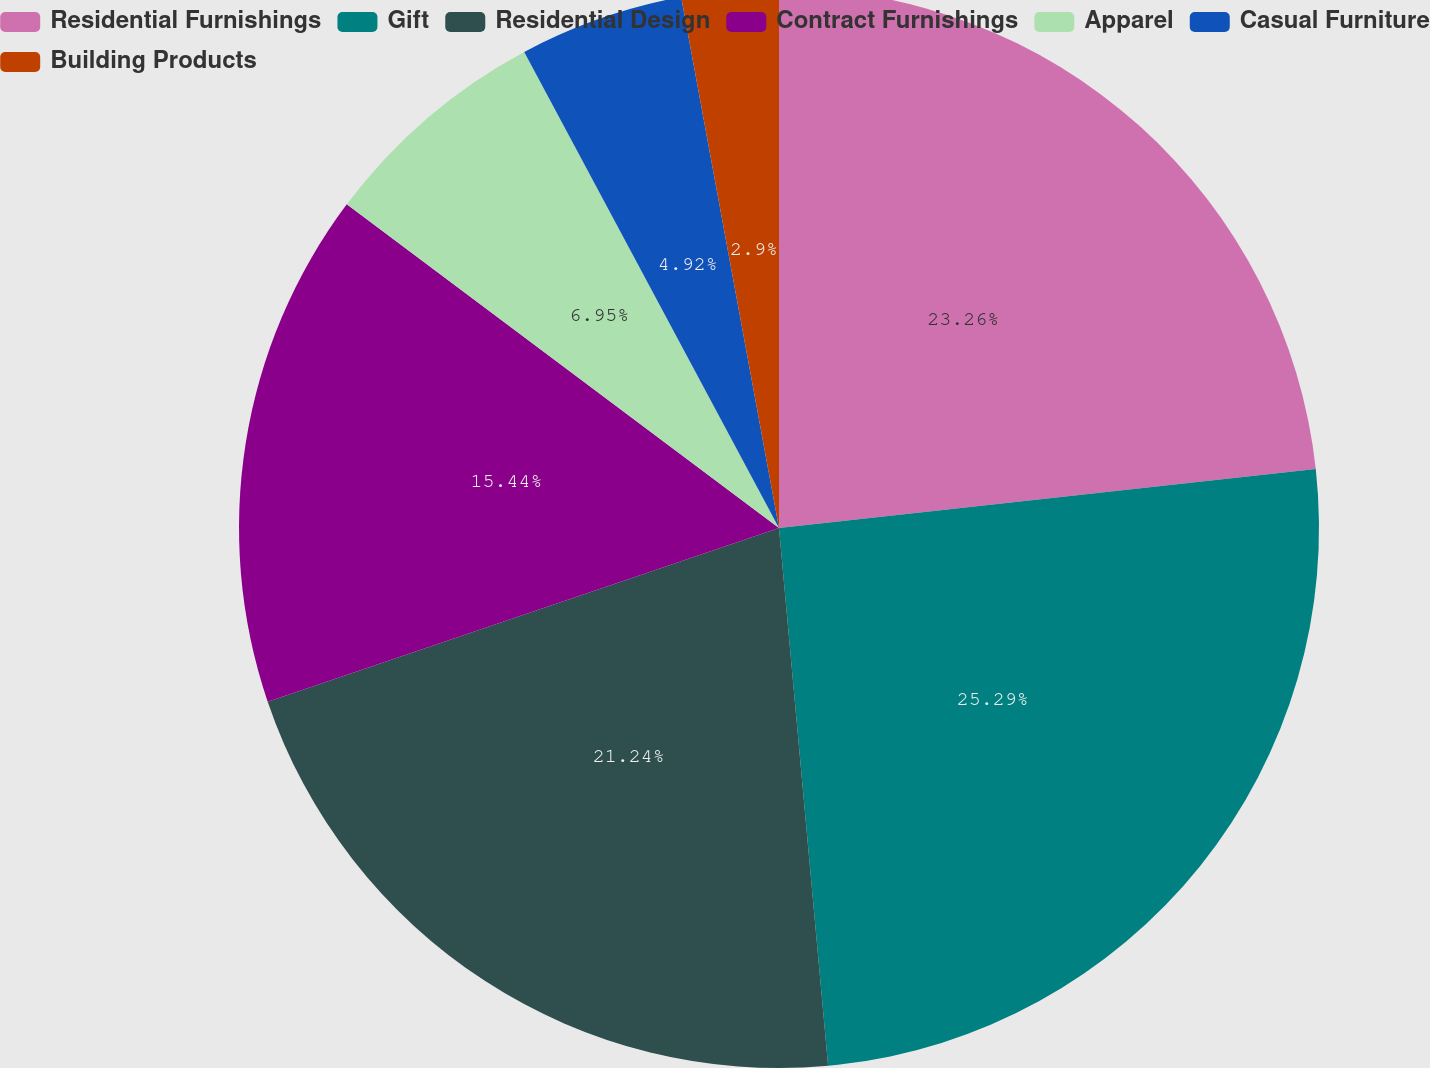Convert chart to OTSL. <chart><loc_0><loc_0><loc_500><loc_500><pie_chart><fcel>Residential Furnishings<fcel>Gift<fcel>Residential Design<fcel>Contract Furnishings<fcel>Apparel<fcel>Casual Furniture<fcel>Building Products<nl><fcel>23.26%<fcel>25.29%<fcel>21.24%<fcel>15.44%<fcel>6.95%<fcel>4.92%<fcel>2.9%<nl></chart> 